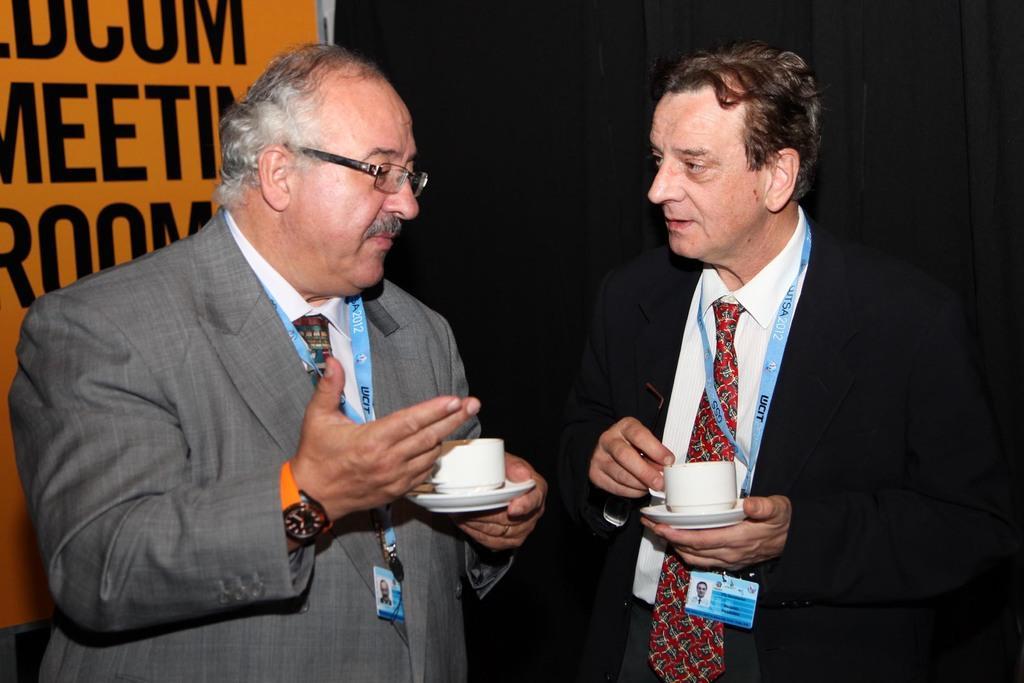Please provide a concise description of this image. In the picture we can see two men are standing and talking to each other and they are in blazers, ties, shirts and ID cards with tags and they are holding cup and saucers in their hands and behind a man we can see a part of a banner with something written on it. 